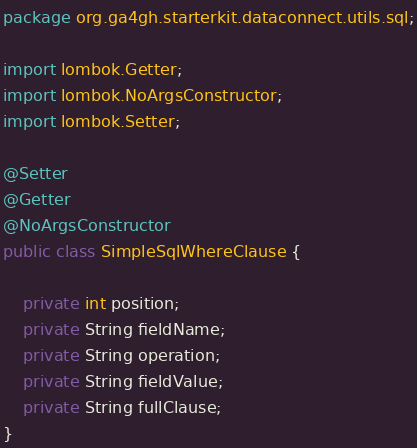<code> <loc_0><loc_0><loc_500><loc_500><_Java_>package org.ga4gh.starterkit.dataconnect.utils.sql;

import lombok.Getter;
import lombok.NoArgsConstructor;
import lombok.Setter;

@Setter
@Getter
@NoArgsConstructor
public class SimpleSqlWhereClause {

    private int position;
    private String fieldName;
    private String operation;
    private String fieldValue;
    private String fullClause;
}
</code> 